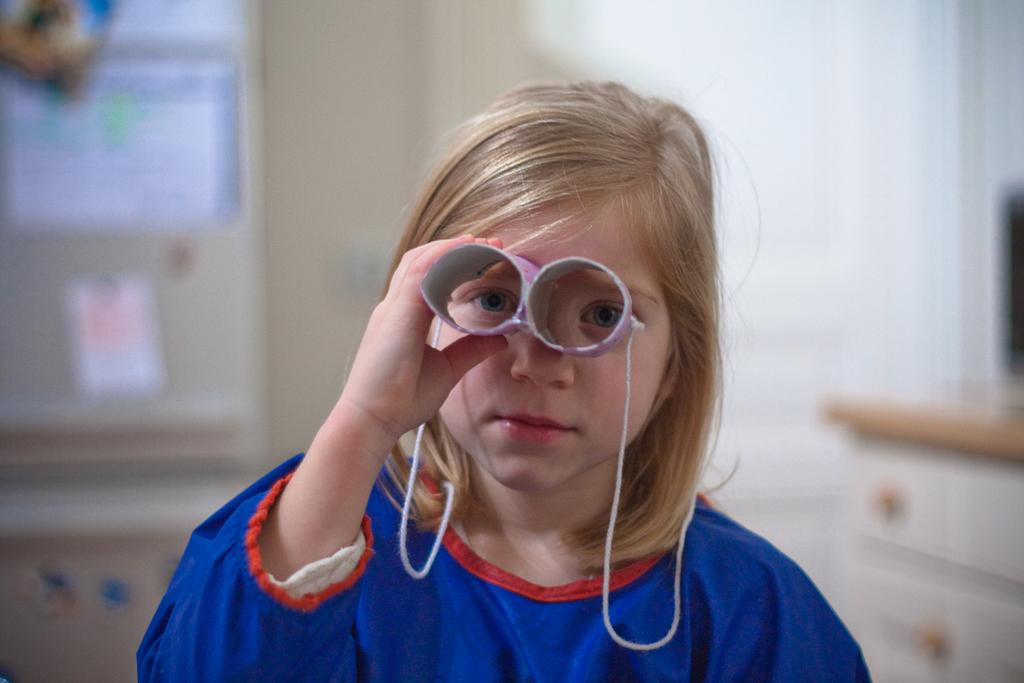Who is the main subject in the foreground of the image? There is a girl in the foreground of the image. What is the girl holding over her face? The girl is holding a cardboard round shape object over her face. Can you describe the background of the image? The background of the image is blurred. What type of plot is the girl standing on in the image? There is no plot visible in the image; the girl is standing on a surface that is not clearly defined. What is the girl using to carry her belongings in the image? There is no basket or any other object used for carrying belongings present in the image. 